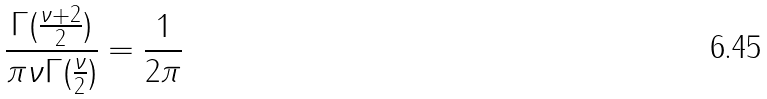Convert formula to latex. <formula><loc_0><loc_0><loc_500><loc_500>\frac { \Gamma ( \frac { \nu + 2 } { 2 } ) } { \pi \nu \Gamma ( \frac { \nu } { 2 } ) } = \frac { 1 } { 2 \pi }</formula> 